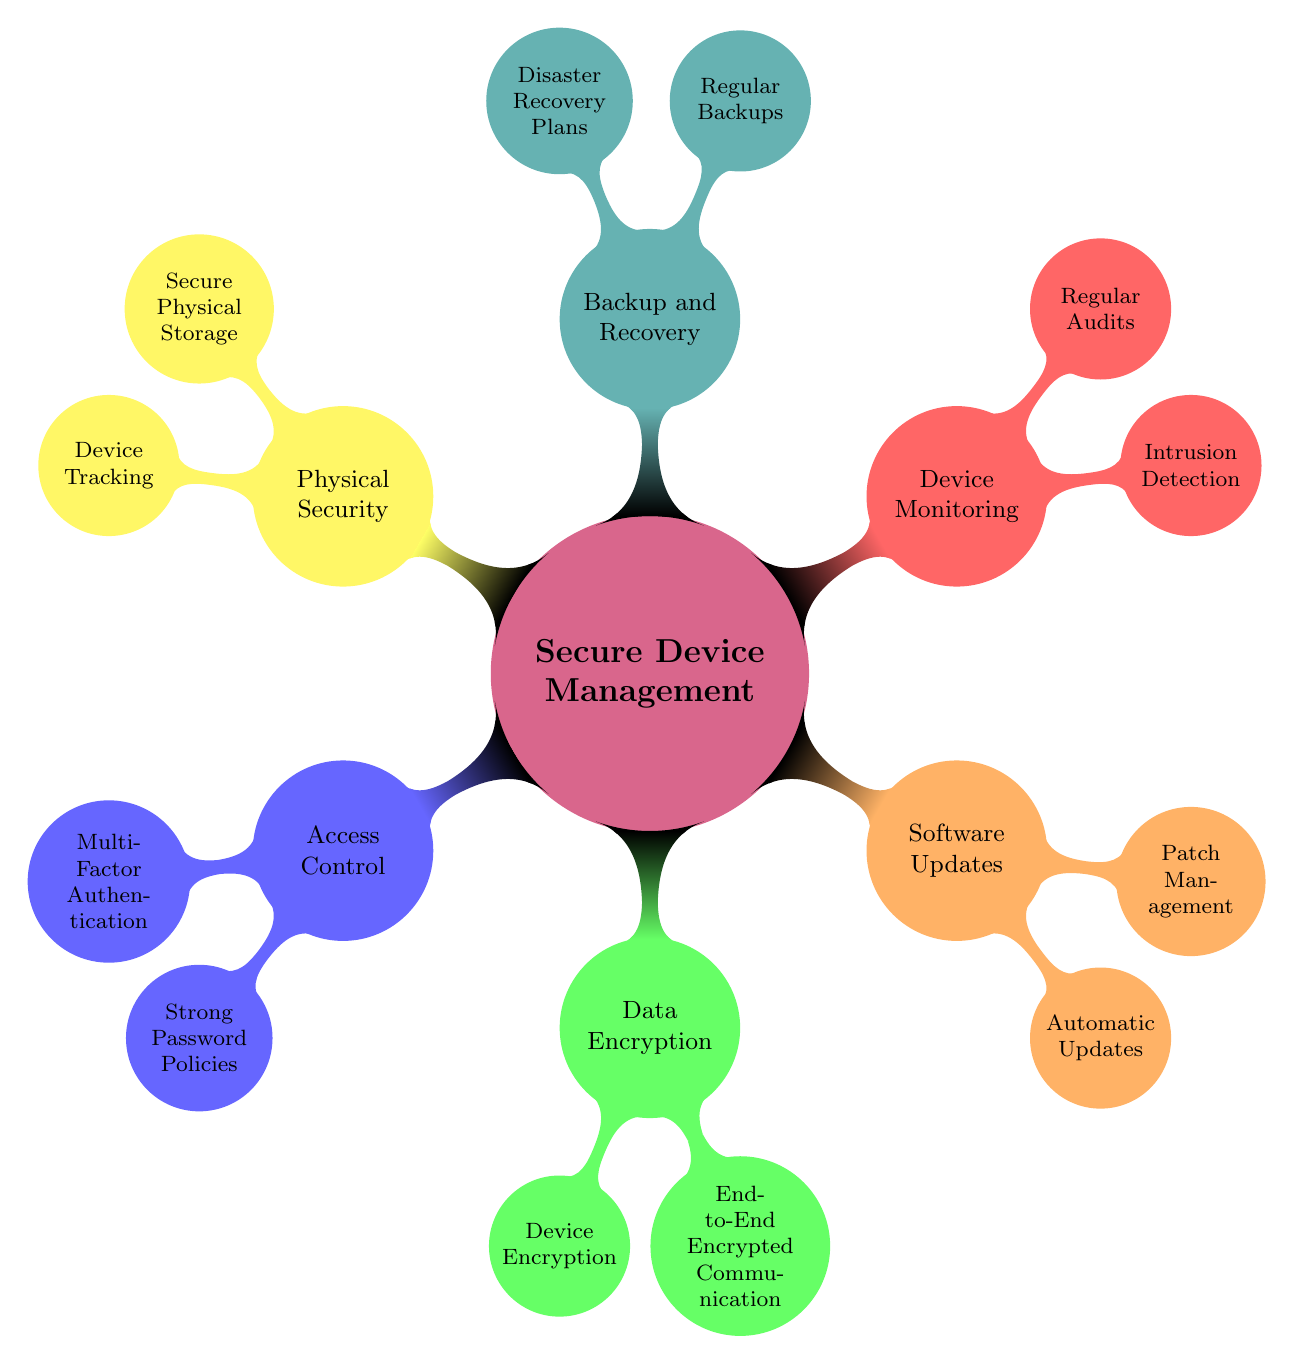What are the two main categories under Secure Device Management? The main categories under Secure Device Management include Access Control and Data Encryption, as indicated in the first layer of the mind map.
Answer: Access Control, Data Encryption How many subcategories does Backup and Recovery have? Looking at the Backup and Recovery node, we can see it has two subcategories listed beneath it: Regular Backups and Disaster Recovery Plans.
Answer: 2 What encryption method is specified for macOS? Under the Data Encryption category, the specific method mentioned for macOS is FileVault, which is explicitly listed.
Answer: FileVault Which item is listed under Device Monitoring that pertains to security checks? In the Device Monitoring section, Regular Audits are mentioned, which pertain to security checks that are conducted to ensure compliance.
Answer: Regular Audits How many total nodes are there in the entire mind map? By counting all nodes shown throughout the mind map, we can conclude there are a total of eleven nodes, including the main and subcategories.
Answer: 11 What is the purpose of Multi-Factor Authentication? Multi-Factor Authentication, found under Access Control, is intended to enhance security by requiring more than one form of verification.
Answer: Enhance security Which applications are suggested for End-to-End Encrypted Communication? The specific applications suggested for secure communication are Signal App and ProtonMail, which are listed under the appropriate category.
Answer: Signal App, ProtonMail What type of updates are covered under Software Updates? The Software Updates category covers Automatic Updates and Patch Management as key components to ensure software is up to date.
Answer: Automatic Updates, Patch Management What does the concept of Secure Physical Storage include? Under the Physical Security category, Secure Physical Storage includes items like Laptop Locks and Security Cabinets, as indicated in the diagram.
Answer: Laptop Locks, Security Cabinets What type of devices utilize the specified Device Tracking method? The Device Tracking method mentioned, Find My Device, is specifically for devices such as those made by Apple and Google.
Answer: Apple, Google 